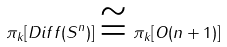Convert formula to latex. <formula><loc_0><loc_0><loc_500><loc_500>\pi _ { k } [ D i f f ( S ^ { n } ) ] \cong \pi _ { k } [ O ( n + 1 ) ]</formula> 